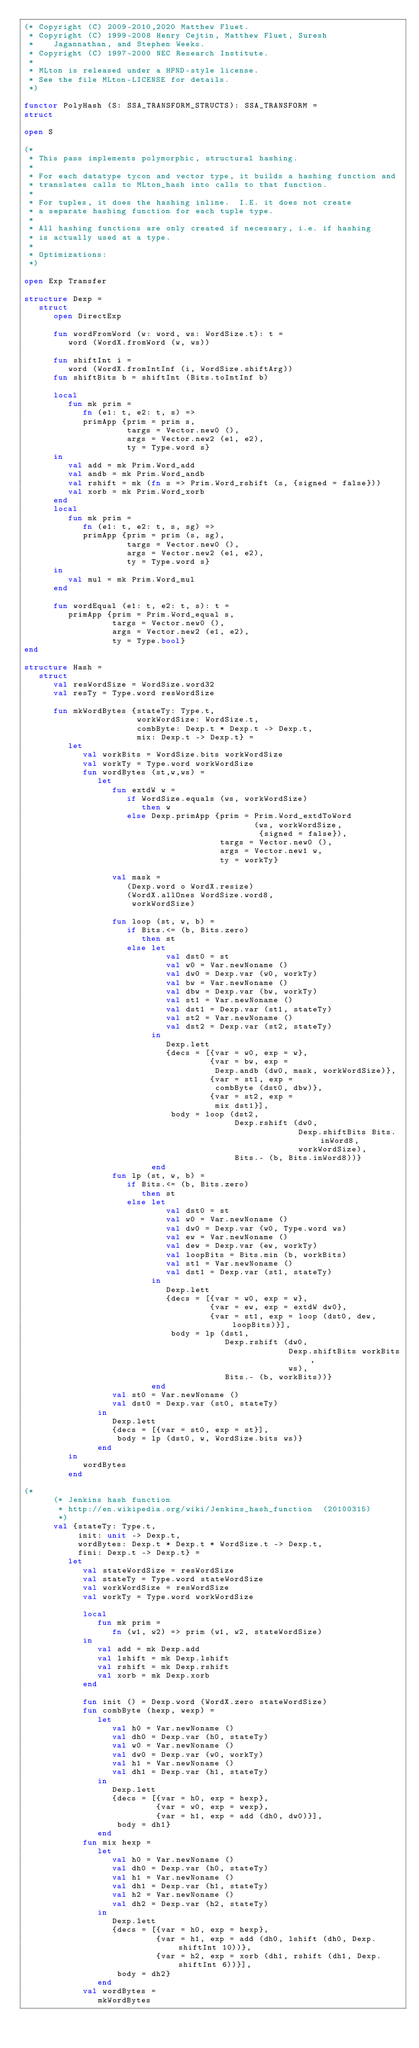Convert code to text. <code><loc_0><loc_0><loc_500><loc_500><_SML_>(* Copyright (C) 2009-2010,2020 Matthew Fluet.
 * Copyright (C) 1999-2008 Henry Cejtin, Matthew Fluet, Suresh
 *    Jagannathan, and Stephen Weeks.
 * Copyright (C) 1997-2000 NEC Research Institute.
 *
 * MLton is released under a HPND-style license.
 * See the file MLton-LICENSE for details.
 *)

functor PolyHash (S: SSA_TRANSFORM_STRUCTS): SSA_TRANSFORM = 
struct

open S

(*
 * This pass implements polymorphic, structural hashing.
 *
 * For each datatype tycon and vector type, it builds a hashing function and
 * translates calls to MLton_hash into calls to that function.
 *
 * For tuples, it does the hashing inline.  I.E. it does not create
 * a separate hashing function for each tuple type.
 *
 * All hashing functions are only created if necessary, i.e. if hashing
 * is actually used at a type.
 *
 * Optimizations:
 *)

open Exp Transfer

structure Dexp =
   struct
      open DirectExp

      fun wordFromWord (w: word, ws: WordSize.t): t =
         word (WordX.fromWord (w, ws))

      fun shiftInt i =
         word (WordX.fromIntInf (i, WordSize.shiftArg))
      fun shiftBits b = shiftInt (Bits.toIntInf b)

      local
         fun mk prim =
            fn (e1: t, e2: t, s) =>
            primApp {prim = prim s,
                     targs = Vector.new0 (),
                     args = Vector.new2 (e1, e2),
                     ty = Type.word s}
      in
         val add = mk Prim.Word_add
         val andb = mk Prim.Word_andb
         val rshift = mk (fn s => Prim.Word_rshift (s, {signed = false}))
         val xorb = mk Prim.Word_xorb
      end
      local
         fun mk prim =
            fn (e1: t, e2: t, s, sg) =>
            primApp {prim = prim (s, sg),
                     targs = Vector.new0 (),
                     args = Vector.new2 (e1, e2),
                     ty = Type.word s}
      in
         val mul = mk Prim.Word_mul
      end

      fun wordEqual (e1: t, e2: t, s): t =
         primApp {prim = Prim.Word_equal s,
                  targs = Vector.new0 (),
                  args = Vector.new2 (e1, e2),
                  ty = Type.bool}
end

structure Hash =
   struct
      val resWordSize = WordSize.word32
      val resTy = Type.word resWordSize

      fun mkWordBytes {stateTy: Type.t,
                       workWordSize: WordSize.t,
                       combByte: Dexp.t * Dexp.t -> Dexp.t,
                       mix: Dexp.t -> Dexp.t} =
         let
            val workBits = WordSize.bits workWordSize
            val workTy = Type.word workWordSize
            fun wordBytes (st,w,ws) =
               let
                  fun extdW w =
                     if WordSize.equals (ws, workWordSize)
                        then w
                     else Dexp.primApp {prim = Prim.Word_extdToWord
                                               (ws, workWordSize, 
                                                {signed = false}),
                                        targs = Vector.new0 (),
                                        args = Vector.new1 w,
                                        ty = workTy}

                  val mask = 
                     (Dexp.word o WordX.resize) 
                     (WordX.allOnes WordSize.word8, 
                      workWordSize)

                  fun loop (st, w, b) =
                     if Bits.<= (b, Bits.zero)
                        then st
                     else let
                             val dst0 = st
                             val w0 = Var.newNoname ()
                             val dw0 = Dexp.var (w0, workTy)
                             val bw = Var.newNoname ()
                             val dbw = Dexp.var (bw, workTy)
                             val st1 = Var.newNoname ()
                             val dst1 = Dexp.var (st1, stateTy)
                             val st2 = Var.newNoname ()
                             val dst2 = Dexp.var (st2, stateTy)
                          in
                             Dexp.lett
                             {decs = [{var = w0, exp = w},
                                      {var = bw, exp = 
                                       Dexp.andb (dw0, mask, workWordSize)},
                                      {var = st1, exp = 
                                       combByte (dst0, dbw)},
                                      {var = st2, exp = 
                                       mix dst1}],
                              body = loop (dst2, 
                                           Dexp.rshift (dw0, 
                                                        Dexp.shiftBits Bits.inWord8, 
                                                        workWordSize),
                                           Bits.- (b, Bits.inWord8))}
                          end
                  fun lp (st, w, b) =
                     if Bits.<= (b, Bits.zero)
                        then st
                     else let
                             val dst0 = st
                             val w0 = Var.newNoname ()
                             val dw0 = Dexp.var (w0, Type.word ws)
                             val ew = Var.newNoname ()
                             val dew = Dexp.var (ew, workTy)
                             val loopBits = Bits.min (b, workBits)
                             val st1 = Var.newNoname ()
                             val dst1 = Dexp.var (st1, stateTy)
                          in
                             Dexp.lett
                             {decs = [{var = w0, exp = w},
                                      {var = ew, exp = extdW dw0},
                                      {var = st1, exp = loop (dst0, dew, loopBits)}],
                              body = lp (dst1, 
                                         Dexp.rshift (dw0, 
                                                      Dexp.shiftBits workBits, 
                                                      ws),
                                         Bits.- (b, workBits))}
                          end
                  val st0 = Var.newNoname ()
                  val dst0 = Dexp.var (st0, stateTy)
               in
                  Dexp.lett
                  {decs = [{var = st0, exp = st}],
                   body = lp (dst0, w, WordSize.bits ws)}
               end
         in
            wordBytes
         end

(*
      (* Jenkins hash function
       * http://en.wikipedia.org/wiki/Jenkins_hash_function  (20100315)
       *) 
      val {stateTy: Type.t,
           init: unit -> Dexp.t,
           wordBytes: Dexp.t * Dexp.t * WordSize.t -> Dexp.t,
           fini: Dexp.t -> Dexp.t} =
         let
            val stateWordSize = resWordSize
            val stateTy = Type.word stateWordSize
            val workWordSize = resWordSize
            val workTy = Type.word workWordSize

            local
               fun mk prim =
                  fn (w1, w2) => prim (w1, w2, stateWordSize)
            in
               val add = mk Dexp.add
               val lshift = mk Dexp.lshift
               val rshift = mk Dexp.rshift
               val xorb = mk Dexp.xorb
            end

            fun init () = Dexp.word (WordX.zero stateWordSize)
            fun combByte (hexp, wexp) =
               let
                  val h0 = Var.newNoname ()
                  val dh0 = Dexp.var (h0, stateTy)
                  val w0 = Var.newNoname ()
                  val dw0 = Dexp.var (w0, workTy)
                  val h1 = Var.newNoname ()
                  val dh1 = Dexp.var (h1, stateTy)
               in
                  Dexp.lett
                  {decs = [{var = h0, exp = hexp},
                           {var = w0, exp = wexp},
                           {var = h1, exp = add (dh0, dw0)}],
                   body = dh1}
               end
            fun mix hexp =
               let
                  val h0 = Var.newNoname ()
                  val dh0 = Dexp.var (h0, stateTy)
                  val h1 = Var.newNoname ()
                  val dh1 = Dexp.var (h1, stateTy)
                  val h2 = Var.newNoname ()
                  val dh2 = Dexp.var (h2, stateTy)
               in
                  Dexp.lett
                  {decs = [{var = h0, exp = hexp},
                           {var = h1, exp = add (dh0, lshift (dh0, Dexp.shiftInt 10))},
                           {var = h2, exp = xorb (dh1, rshift (dh1, Dexp.shiftInt 6))}],
                   body = dh2}
               end
            val wordBytes =
               mkWordBytes</code> 